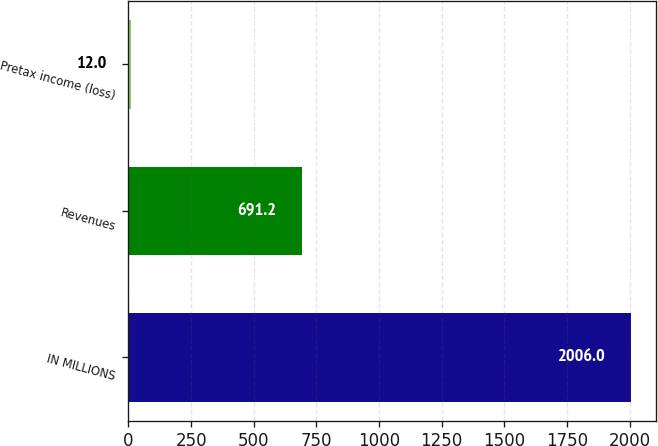Convert chart to OTSL. <chart><loc_0><loc_0><loc_500><loc_500><bar_chart><fcel>IN MILLIONS<fcel>Revenues<fcel>Pretax income (loss)<nl><fcel>2006<fcel>691.2<fcel>12<nl></chart> 